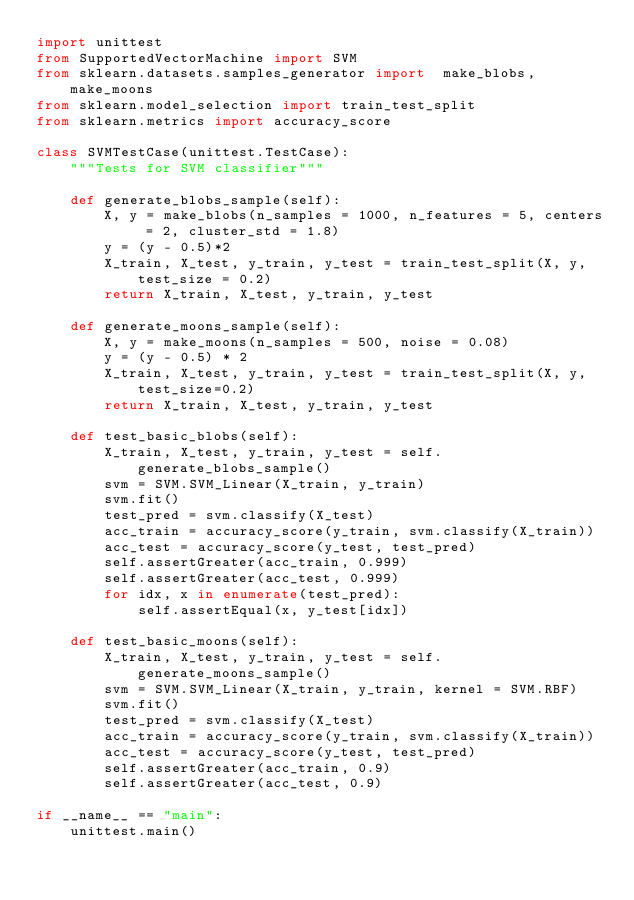<code> <loc_0><loc_0><loc_500><loc_500><_Python_>import unittest
from SupportedVectorMachine import SVM
from sklearn.datasets.samples_generator import  make_blobs, make_moons
from sklearn.model_selection import train_test_split
from sklearn.metrics import accuracy_score

class SVMTestCase(unittest.TestCase):
    """Tests for SVM classifier"""

    def generate_blobs_sample(self):
        X, y = make_blobs(n_samples = 1000, n_features = 5, centers = 2, cluster_std = 1.8)
        y = (y - 0.5)*2
        X_train, X_test, y_train, y_test = train_test_split(X, y, test_size = 0.2)
        return X_train, X_test, y_train, y_test

    def generate_moons_sample(self):
        X, y = make_moons(n_samples = 500, noise = 0.08)
        y = (y - 0.5) * 2
        X_train, X_test, y_train, y_test = train_test_split(X, y, test_size=0.2)
        return X_train, X_test, y_train, y_test

    def test_basic_blobs(self):
        X_train, X_test, y_train, y_test = self.generate_blobs_sample()
        svm = SVM.SVM_Linear(X_train, y_train)
        svm.fit()
        test_pred = svm.classify(X_test)
        acc_train = accuracy_score(y_train, svm.classify(X_train))
        acc_test = accuracy_score(y_test, test_pred)
        self.assertGreater(acc_train, 0.999)
        self.assertGreater(acc_test, 0.999)
        for idx, x in enumerate(test_pred):
            self.assertEqual(x, y_test[idx])

    def test_basic_moons(self):
        X_train, X_test, y_train, y_test = self.generate_moons_sample()
        svm = SVM.SVM_Linear(X_train, y_train, kernel = SVM.RBF)
        svm.fit()
        test_pred = svm.classify(X_test)
        acc_train = accuracy_score(y_train, svm.classify(X_train))
        acc_test = accuracy_score(y_test, test_pred)
        self.assertGreater(acc_train, 0.9)
        self.assertGreater(acc_test, 0.9)

if __name__ == "main":
    unittest.main()

</code> 